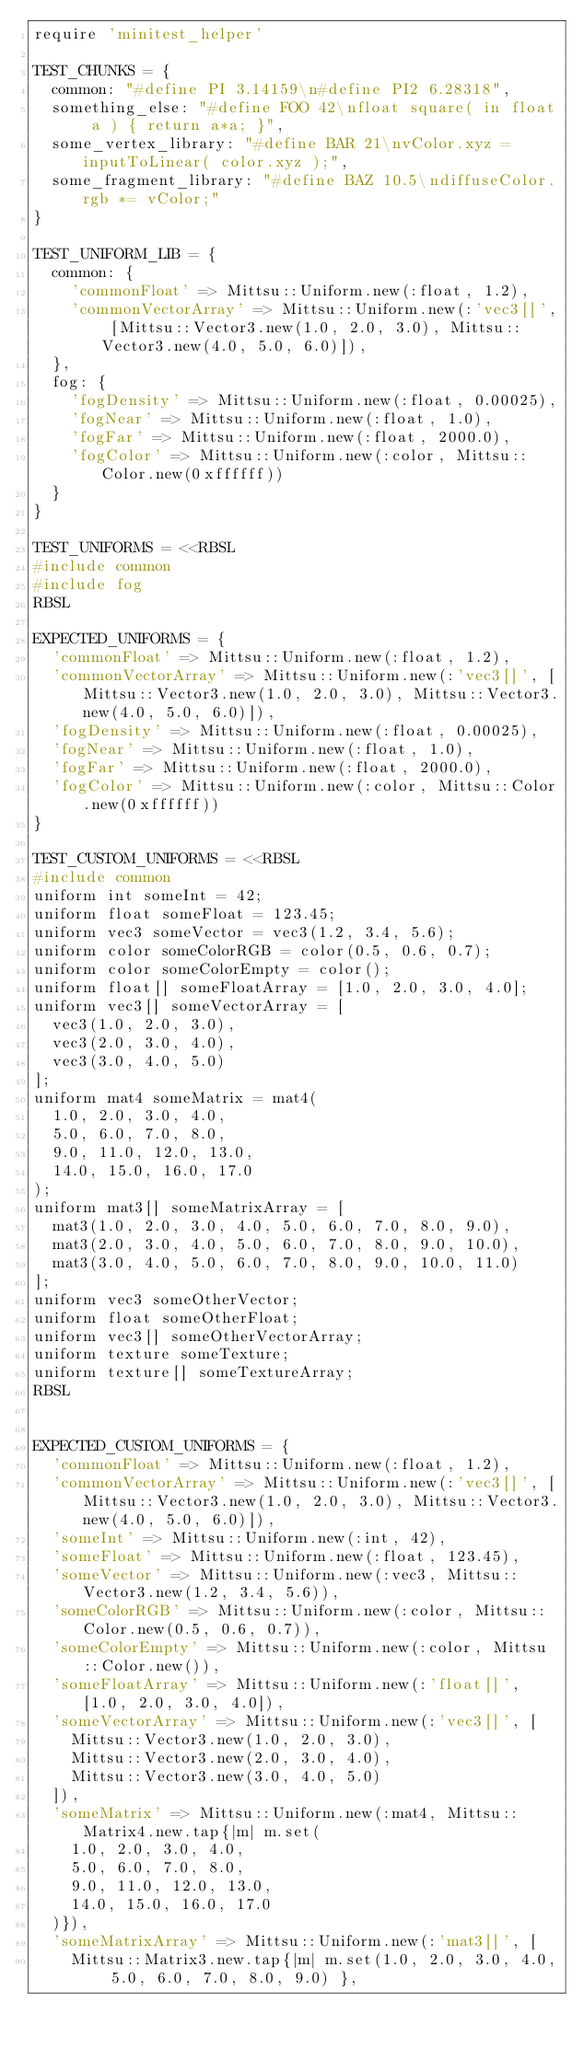Convert code to text. <code><loc_0><loc_0><loc_500><loc_500><_Ruby_>require 'minitest_helper'

TEST_CHUNKS = {
  common: "#define PI 3.14159\n#define PI2 6.28318",
  something_else: "#define FOO 42\nfloat square( in float a ) { return a*a; }",
  some_vertex_library: "#define BAR 21\nvColor.xyz = inputToLinear( color.xyz );",
  some_fragment_library: "#define BAZ 10.5\ndiffuseColor.rgb *= vColor;"
}

TEST_UNIFORM_LIB = {
  common: {
    'commonFloat' => Mittsu::Uniform.new(:float, 1.2),
    'commonVectorArray' => Mittsu::Uniform.new(:'vec3[]', [Mittsu::Vector3.new(1.0, 2.0, 3.0), Mittsu::Vector3.new(4.0, 5.0, 6.0)]),
  },
  fog: {
    'fogDensity' => Mittsu::Uniform.new(:float, 0.00025),
    'fogNear' => Mittsu::Uniform.new(:float, 1.0),
    'fogFar' => Mittsu::Uniform.new(:float, 2000.0),
    'fogColor' => Mittsu::Uniform.new(:color, Mittsu::Color.new(0xffffff))
  }
}

TEST_UNIFORMS = <<RBSL
#include common
#include fog
RBSL

EXPECTED_UNIFORMS = {
  'commonFloat' => Mittsu::Uniform.new(:float, 1.2),
  'commonVectorArray' => Mittsu::Uniform.new(:'vec3[]', [Mittsu::Vector3.new(1.0, 2.0, 3.0), Mittsu::Vector3.new(4.0, 5.0, 6.0)]),
  'fogDensity' => Mittsu::Uniform.new(:float, 0.00025),
  'fogNear' => Mittsu::Uniform.new(:float, 1.0),
  'fogFar' => Mittsu::Uniform.new(:float, 2000.0),
  'fogColor' => Mittsu::Uniform.new(:color, Mittsu::Color.new(0xffffff))
}

TEST_CUSTOM_UNIFORMS = <<RBSL
#include common
uniform int someInt = 42;
uniform float someFloat = 123.45;
uniform vec3 someVector = vec3(1.2, 3.4, 5.6);
uniform color someColorRGB = color(0.5, 0.6, 0.7);
uniform color someColorEmpty = color();
uniform float[] someFloatArray = [1.0, 2.0, 3.0, 4.0];
uniform vec3[] someVectorArray = [
  vec3(1.0, 2.0, 3.0),
  vec3(2.0, 3.0, 4.0),
  vec3(3.0, 4.0, 5.0)
];
uniform mat4 someMatrix = mat4(
  1.0, 2.0, 3.0, 4.0,
  5.0, 6.0, 7.0, 8.0,
  9.0, 11.0, 12.0, 13.0,
  14.0, 15.0, 16.0, 17.0
);
uniform mat3[] someMatrixArray = [
  mat3(1.0, 2.0, 3.0, 4.0, 5.0, 6.0, 7.0, 8.0, 9.0),
  mat3(2.0, 3.0, 4.0, 5.0, 6.0, 7.0, 8.0, 9.0, 10.0),
  mat3(3.0, 4.0, 5.0, 6.0, 7.0, 8.0, 9.0, 10.0, 11.0)
];
uniform vec3 someOtherVector;
uniform float someOtherFloat;
uniform vec3[] someOtherVectorArray;
uniform texture someTexture;
uniform texture[] someTextureArray;
RBSL


EXPECTED_CUSTOM_UNIFORMS = {
  'commonFloat' => Mittsu::Uniform.new(:float, 1.2),
  'commonVectorArray' => Mittsu::Uniform.new(:'vec3[]', [Mittsu::Vector3.new(1.0, 2.0, 3.0), Mittsu::Vector3.new(4.0, 5.0, 6.0)]),
  'someInt' => Mittsu::Uniform.new(:int, 42),
  'someFloat' => Mittsu::Uniform.new(:float, 123.45),
  'someVector' => Mittsu::Uniform.new(:vec3, Mittsu::Vector3.new(1.2, 3.4, 5.6)),
  'someColorRGB' => Mittsu::Uniform.new(:color, Mittsu::Color.new(0.5, 0.6, 0.7)),
  'someColorEmpty' => Mittsu::Uniform.new(:color, Mittsu::Color.new()),
  'someFloatArray' => Mittsu::Uniform.new(:'float[]', [1.0, 2.0, 3.0, 4.0]),
  'someVectorArray' => Mittsu::Uniform.new(:'vec3[]', [
    Mittsu::Vector3.new(1.0, 2.0, 3.0),
    Mittsu::Vector3.new(2.0, 3.0, 4.0),
    Mittsu::Vector3.new(3.0, 4.0, 5.0)
  ]),
  'someMatrix' => Mittsu::Uniform.new(:mat4, Mittsu::Matrix4.new.tap{|m| m.set(
    1.0, 2.0, 3.0, 4.0,
    5.0, 6.0, 7.0, 8.0,
    9.0, 11.0, 12.0, 13.0,
    14.0, 15.0, 16.0, 17.0
  )}),
  'someMatrixArray' => Mittsu::Uniform.new(:'mat3[]', [
    Mittsu::Matrix3.new.tap{|m| m.set(1.0, 2.0, 3.0, 4.0, 5.0, 6.0, 7.0, 8.0, 9.0) },</code> 